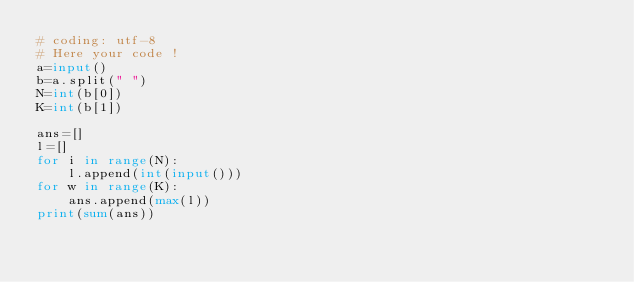<code> <loc_0><loc_0><loc_500><loc_500><_Python_># coding: utf-8
# Here your code !
a=input()
b=a.split(" ")
N=int(b[0])
K=int(b[1])

ans=[]
l=[]
for i in range(N):
    l.append(int(input()))
for w in range(K):
    ans.append(max(l))
print(sum(ans))</code> 